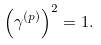Convert formula to latex. <formula><loc_0><loc_0><loc_500><loc_500>\left ( \gamma ^ { ( p ) } \right ) ^ { 2 } = 1 .</formula> 